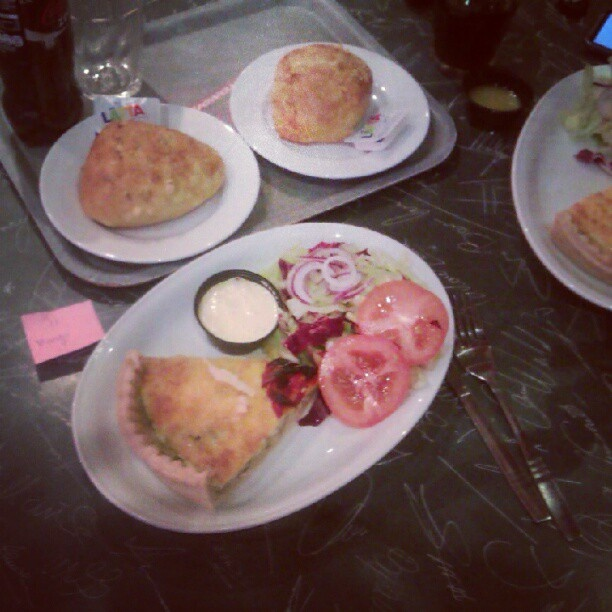Describe the objects in this image and their specific colors. I can see dining table in black, darkgray, gray, and brown tones, sandwich in black, brown, and tan tones, donut in black, gray, and tan tones, cup in black and gray tones, and cup in black, lightgray, gray, and maroon tones in this image. 